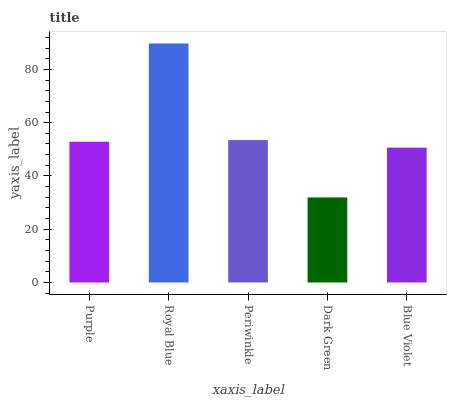Is Dark Green the minimum?
Answer yes or no. Yes. Is Royal Blue the maximum?
Answer yes or no. Yes. Is Periwinkle the minimum?
Answer yes or no. No. Is Periwinkle the maximum?
Answer yes or no. No. Is Royal Blue greater than Periwinkle?
Answer yes or no. Yes. Is Periwinkle less than Royal Blue?
Answer yes or no. Yes. Is Periwinkle greater than Royal Blue?
Answer yes or no. No. Is Royal Blue less than Periwinkle?
Answer yes or no. No. Is Purple the high median?
Answer yes or no. Yes. Is Purple the low median?
Answer yes or no. Yes. Is Royal Blue the high median?
Answer yes or no. No. Is Royal Blue the low median?
Answer yes or no. No. 